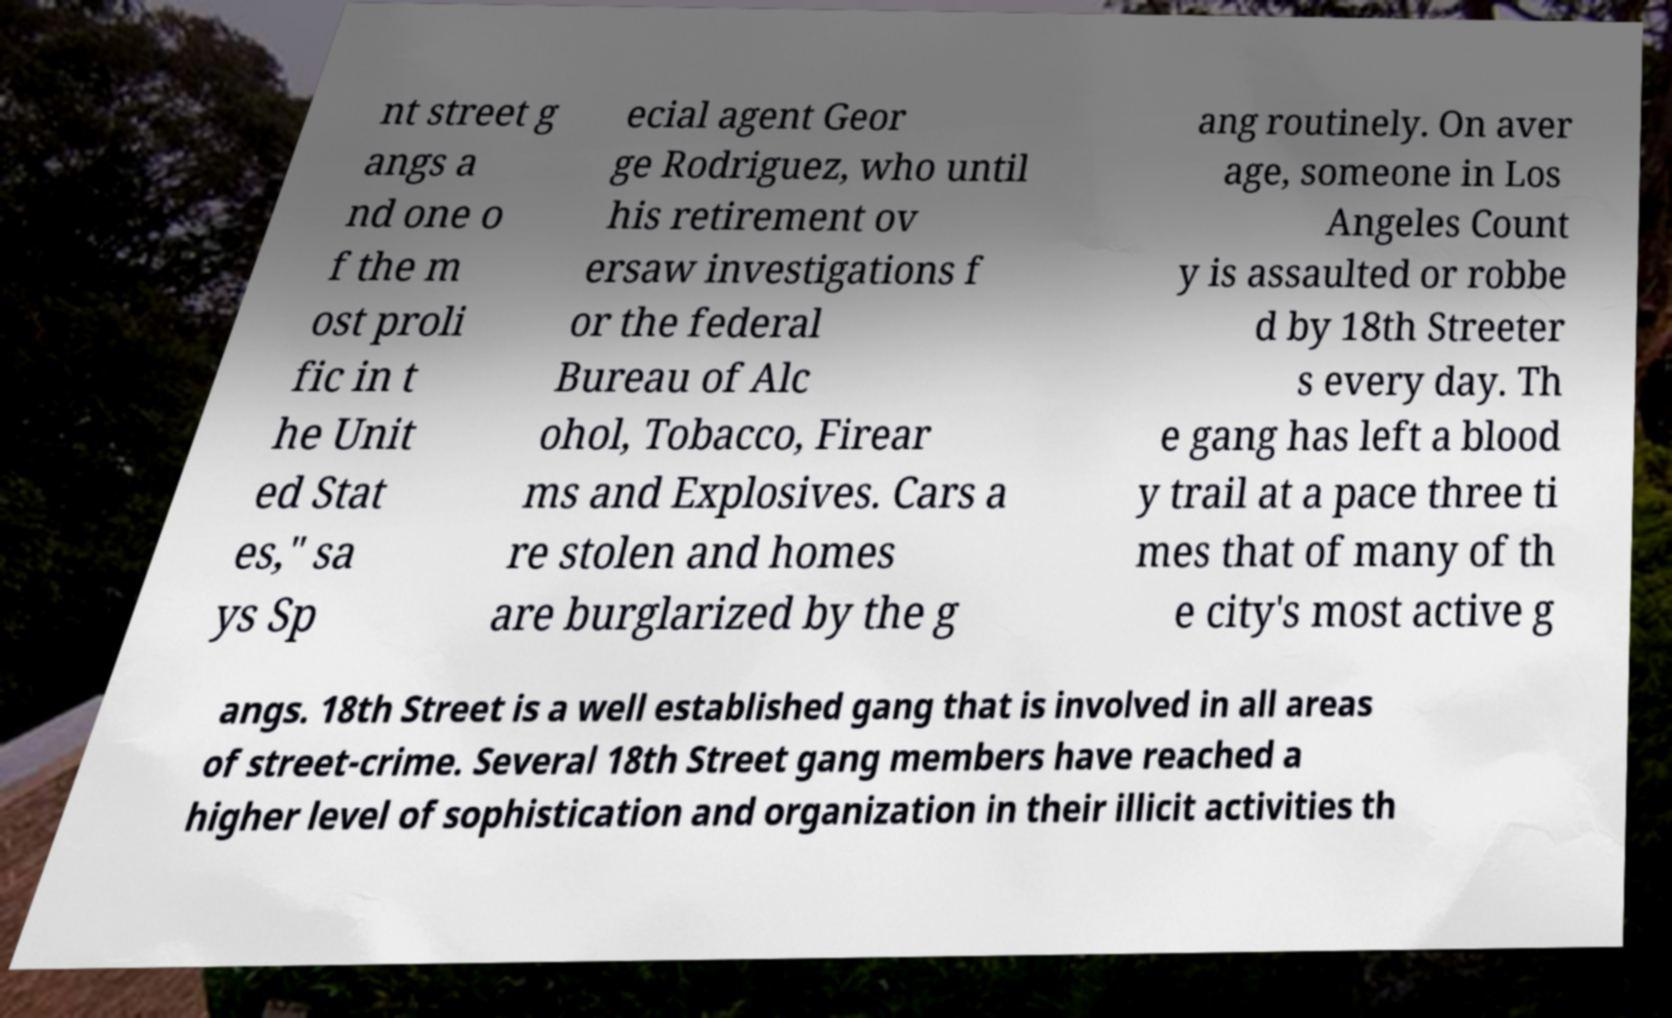There's text embedded in this image that I need extracted. Can you transcribe it verbatim? nt street g angs a nd one o f the m ost proli fic in t he Unit ed Stat es," sa ys Sp ecial agent Geor ge Rodriguez, who until his retirement ov ersaw investigations f or the federal Bureau of Alc ohol, Tobacco, Firear ms and Explosives. Cars a re stolen and homes are burglarized by the g ang routinely. On aver age, someone in Los Angeles Count y is assaulted or robbe d by 18th Streeter s every day. Th e gang has left a blood y trail at a pace three ti mes that of many of th e city's most active g angs. 18th Street is a well established gang that is involved in all areas of street-crime. Several 18th Street gang members have reached a higher level of sophistication and organization in their illicit activities th 